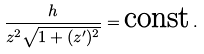Convert formula to latex. <formula><loc_0><loc_0><loc_500><loc_500>\frac { h } { z ^ { 2 } \sqrt { 1 + ( z ^ { \prime } ) ^ { 2 } } } = \text {const} \, .</formula> 